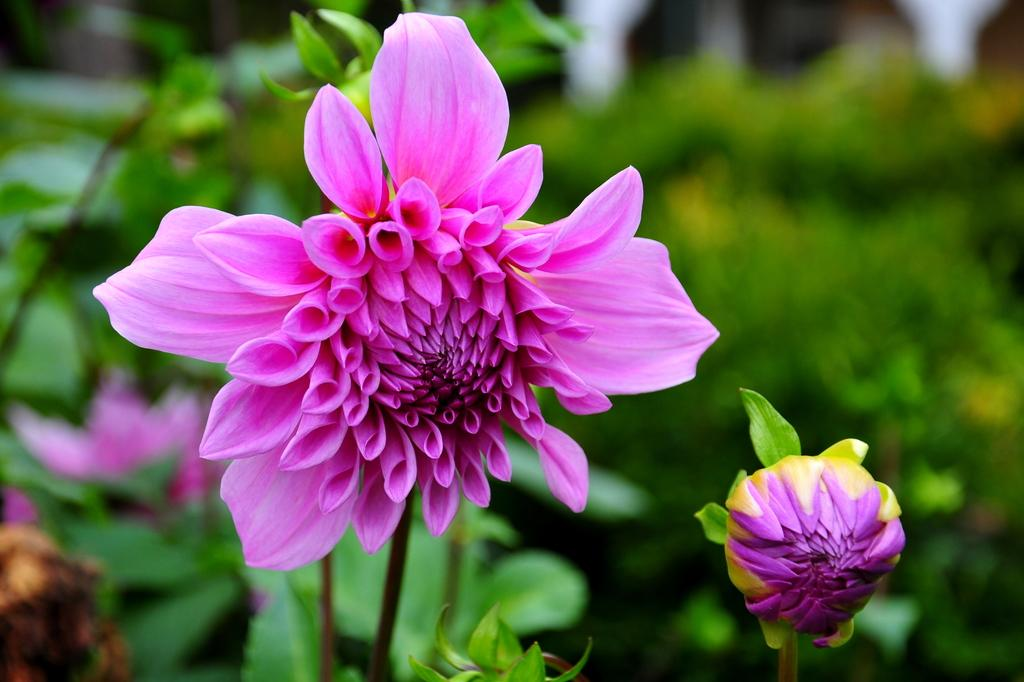What color are the flowers in the image? The flowers in the image are pink. What type of vegetation can be seen in the background of the image? There are green plants in the background of the image. What type of sticks are used to support the brother in the image? There is no brother or sticks present in the image; it only features pink flowers and green plants in the background. 